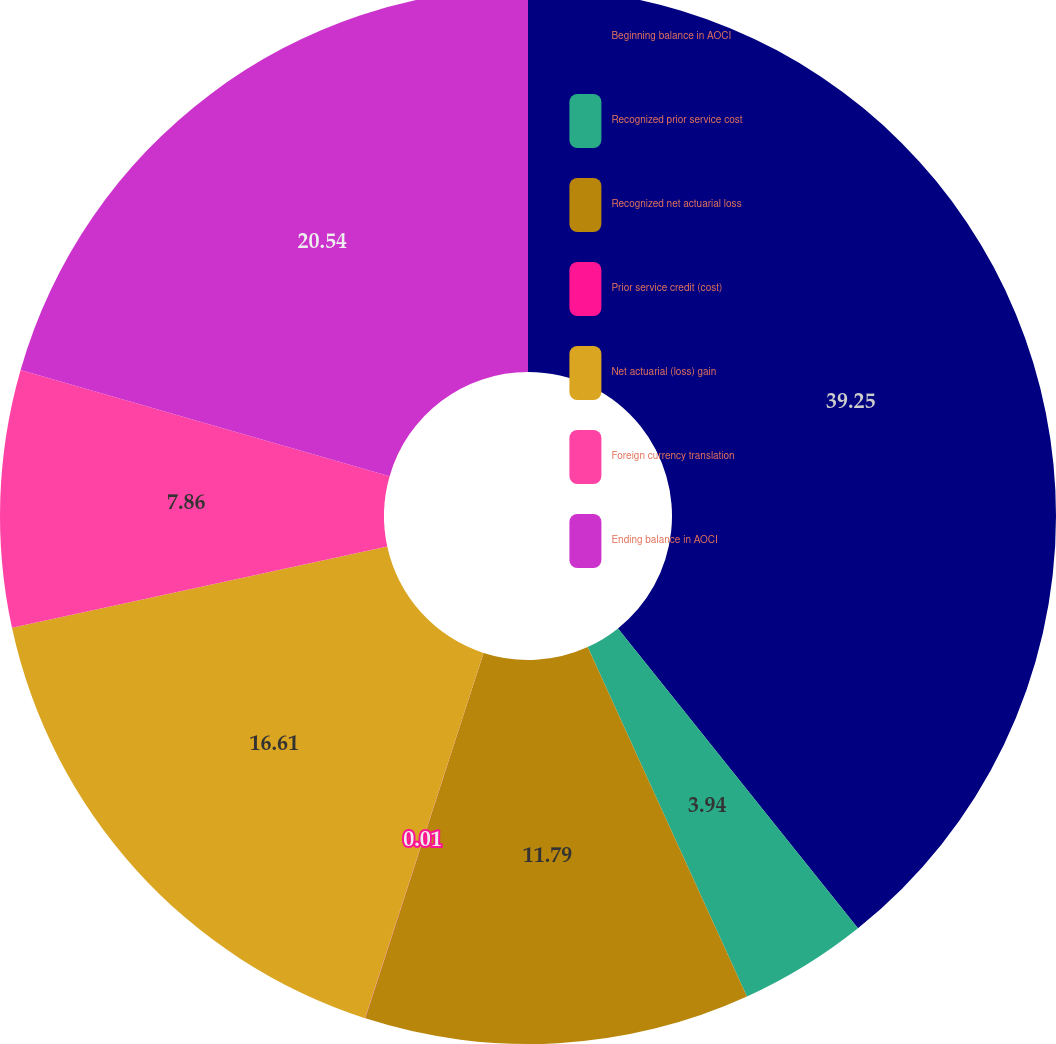Convert chart. <chart><loc_0><loc_0><loc_500><loc_500><pie_chart><fcel>Beginning balance in AOCI<fcel>Recognized prior service cost<fcel>Recognized net actuarial loss<fcel>Prior service credit (cost)<fcel>Net actuarial (loss) gain<fcel>Foreign currency translation<fcel>Ending balance in AOCI<nl><fcel>39.26%<fcel>3.94%<fcel>11.79%<fcel>0.01%<fcel>16.61%<fcel>7.86%<fcel>20.54%<nl></chart> 